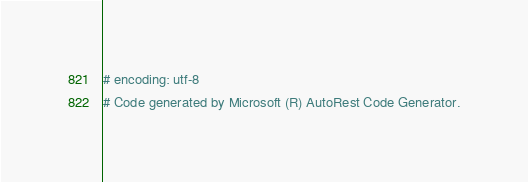Convert code to text. <code><loc_0><loc_0><loc_500><loc_500><_Ruby_># encoding: utf-8
# Code generated by Microsoft (R) AutoRest Code Generator.</code> 